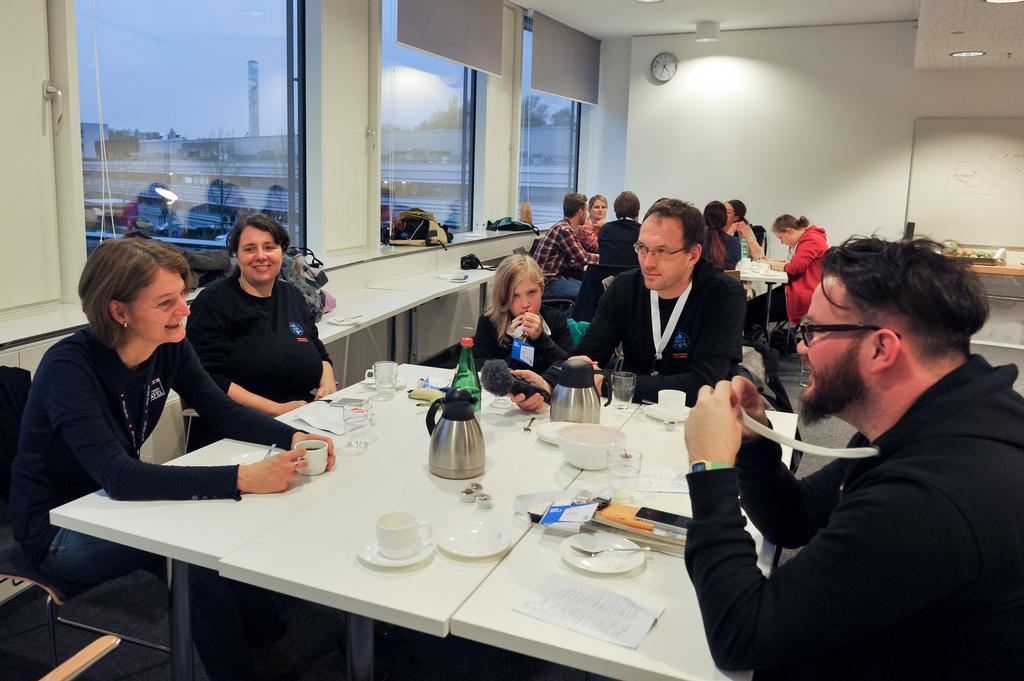Could you give a brief overview of what you see in this image? This is the picture inside of the room. There are group of people sitting around the table. There are cups, saucers, papers, kettles, bottle, bowls on the table. At the left there is a window. At the back there is a clock, light on the wall. At the right there is a board and there are trees, vehicles outside of the window and at the top there is a sky. 